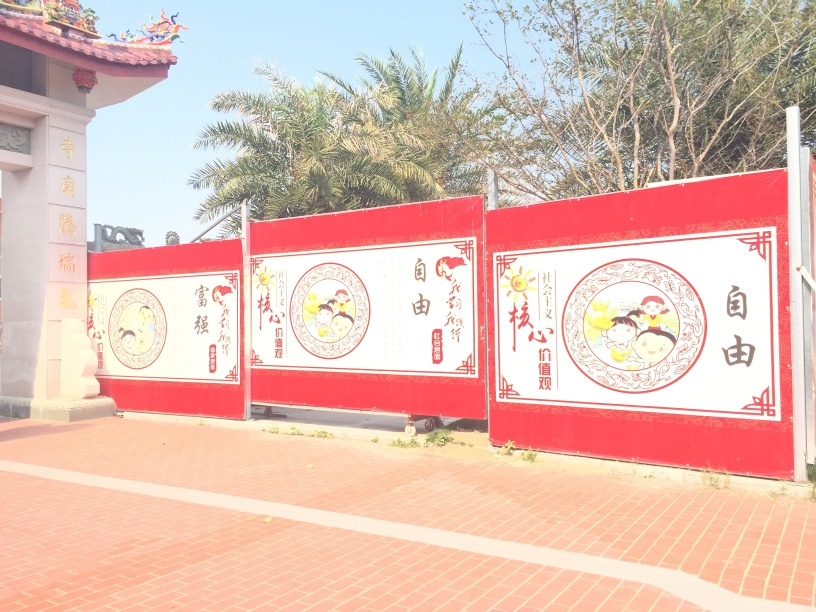How is the image lit? The image features bright, natural daylight that casts soft shadows, indicating that it was taken on a sunny day without direct sunlight on the red panels with illustrations. The lighting is even across the scene, providing a clear view of the details on the panels and the surrounding environment. 